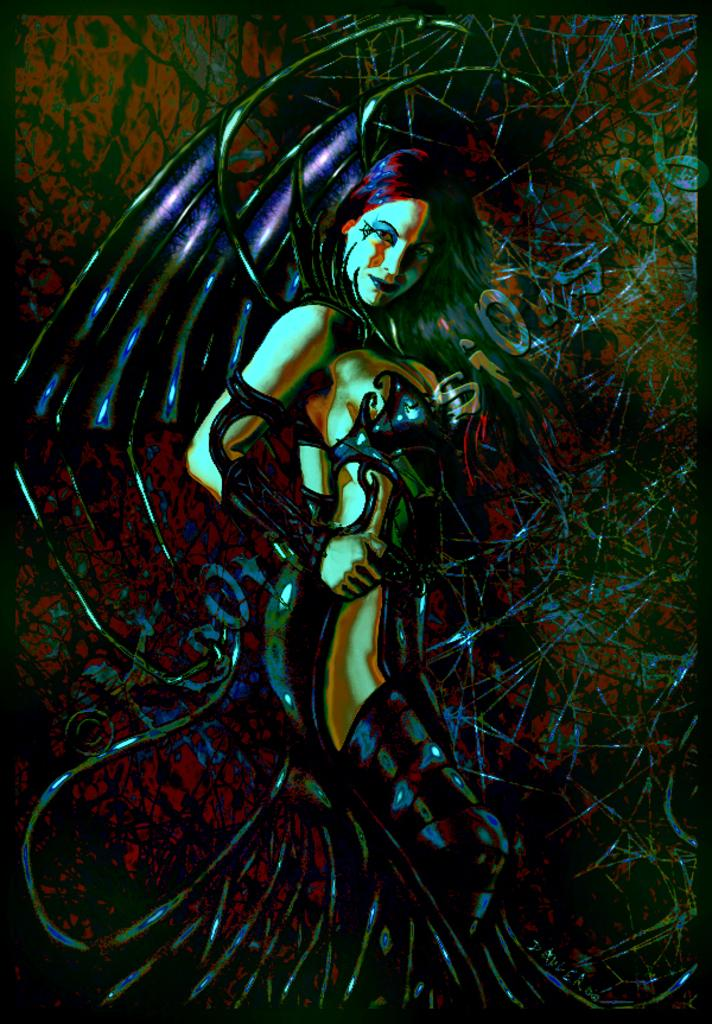What type of content is depicted in the image? There is an animation in the image. Can you describe the main character in the animation? The animation features a lady. What is the lady wearing in the image? The lady is wearing a costume. What type of juice can be seen in the lady's hand in the image? There is no juice present in the image; the lady is wearing a costume in an animation. 